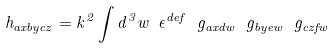<formula> <loc_0><loc_0><loc_500><loc_500>h _ { a x b y c z } = k ^ { 2 } \int d ^ { 3 } w \ \epsilon ^ { d e f } \ g _ { a x d w } \ g _ { b y e w } \ g _ { c z f w }</formula> 